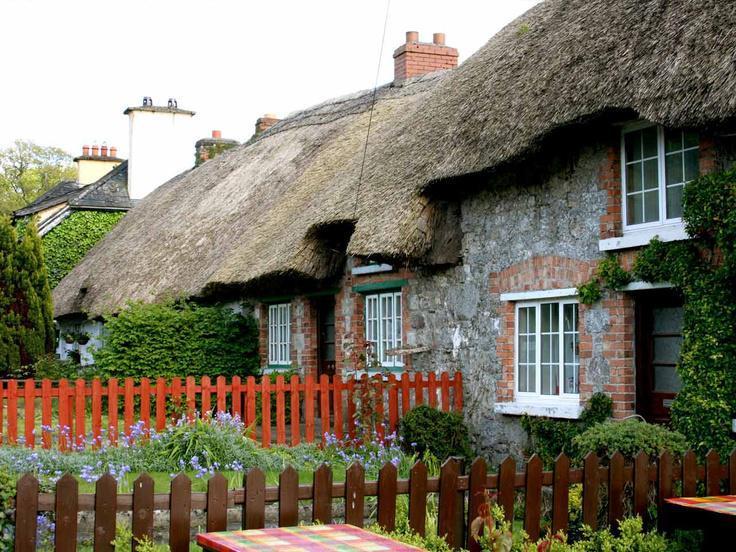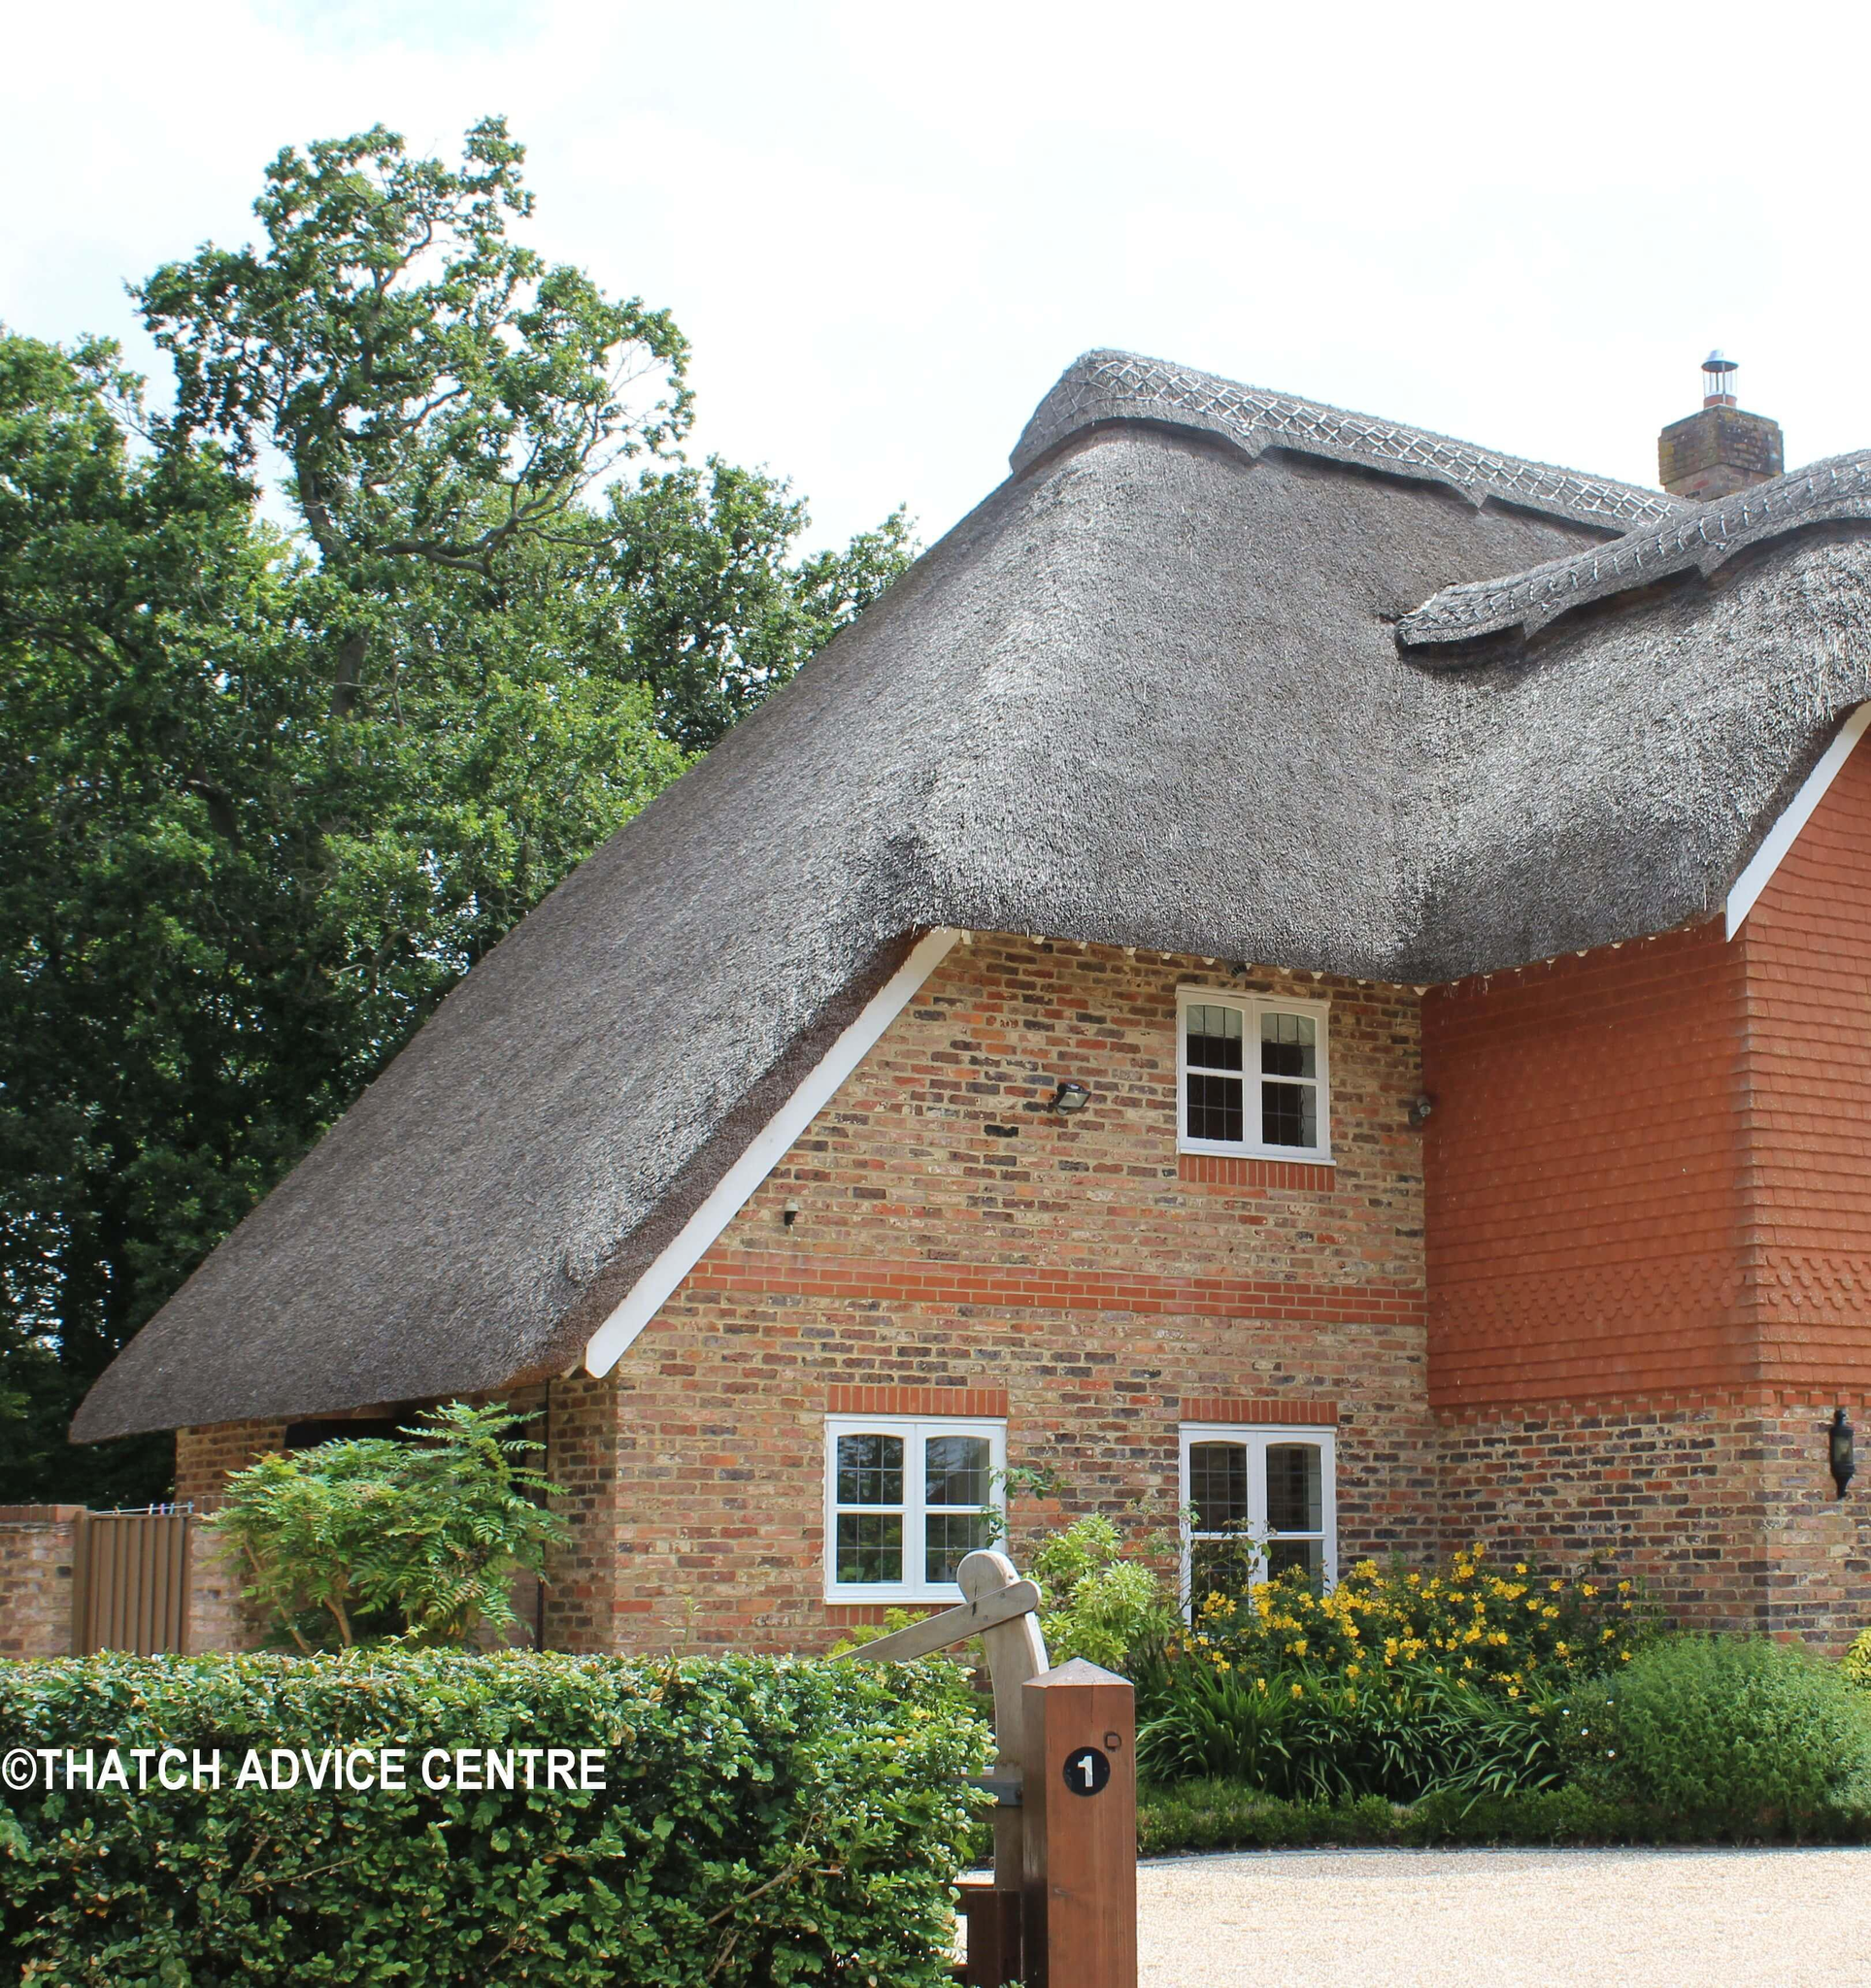The first image is the image on the left, the second image is the image on the right. Assess this claim about the two images: "In the left image, a picket fence is in front of a house with paned windows and a thick grayish roof with at least one notch to accommodate an upper story window.". Correct or not? Answer yes or no. Yes. The first image is the image on the left, the second image is the image on the right. Analyze the images presented: Is the assertion "There is a thatched roof cottage that has a picket fence." valid? Answer yes or no. Yes. 